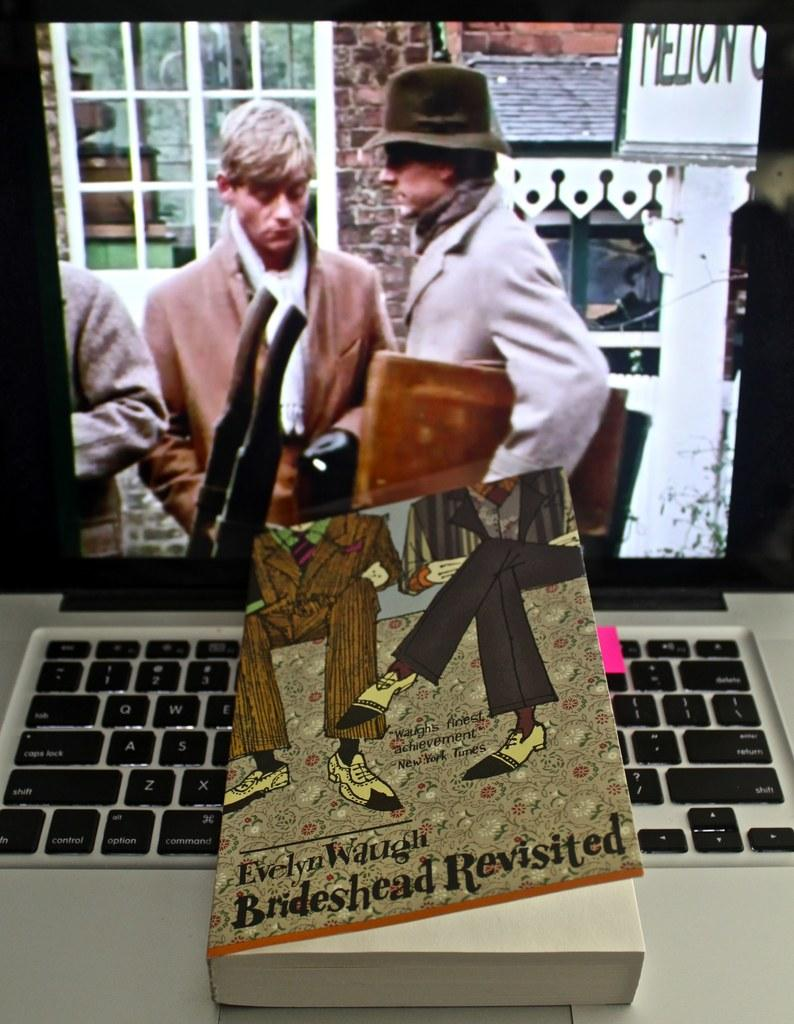What electronic device is present in the image? There is a laptop in the image. What feature of the laptop is visible in the image? The laptop has a screen. What can be seen on the laptop screen? There are persons visible on the laptop screen. What type of content is displayed on the book shown on the laptop? There is an image and text on the book shown on the laptop. What type of plants can be seen growing on the laptop screen? There are no plants visible on the laptop screen; it displays persons. What type of skin condition is visible on the persons shown on the laptop screen? There is no information about skin conditions visible on the persons shown on the laptop screen. 